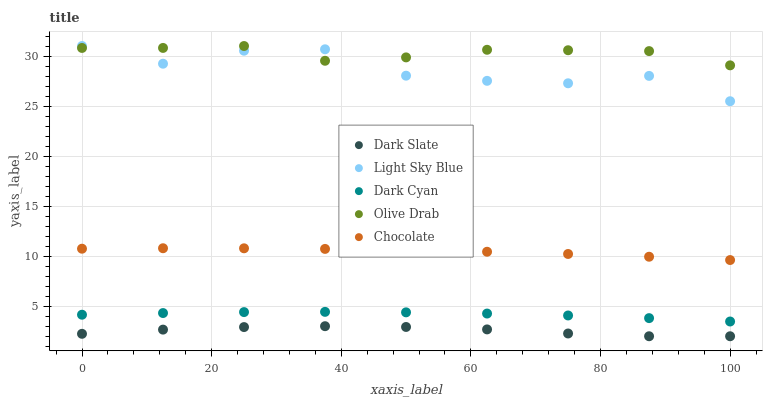Does Dark Slate have the minimum area under the curve?
Answer yes or no. Yes. Does Olive Drab have the maximum area under the curve?
Answer yes or no. Yes. Does Light Sky Blue have the minimum area under the curve?
Answer yes or no. No. Does Light Sky Blue have the maximum area under the curve?
Answer yes or no. No. Is Chocolate the smoothest?
Answer yes or no. Yes. Is Light Sky Blue the roughest?
Answer yes or no. Yes. Is Dark Slate the smoothest?
Answer yes or no. No. Is Dark Slate the roughest?
Answer yes or no. No. Does Dark Slate have the lowest value?
Answer yes or no. Yes. Does Light Sky Blue have the lowest value?
Answer yes or no. No. Does Olive Drab have the highest value?
Answer yes or no. Yes. Does Dark Slate have the highest value?
Answer yes or no. No. Is Dark Slate less than Chocolate?
Answer yes or no. Yes. Is Chocolate greater than Dark Cyan?
Answer yes or no. Yes. Does Olive Drab intersect Light Sky Blue?
Answer yes or no. Yes. Is Olive Drab less than Light Sky Blue?
Answer yes or no. No. Is Olive Drab greater than Light Sky Blue?
Answer yes or no. No. Does Dark Slate intersect Chocolate?
Answer yes or no. No. 